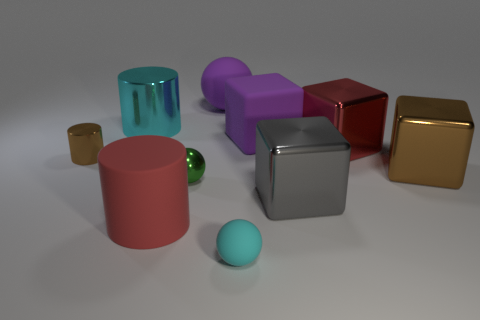What shape is the cyan thing that is the same size as the red cylinder? The cyan object that matches the size of the red cylinder is also a cylinder. It has a circular top view and a cylindrical side view, similar in height and diameter to the red cylinder. 